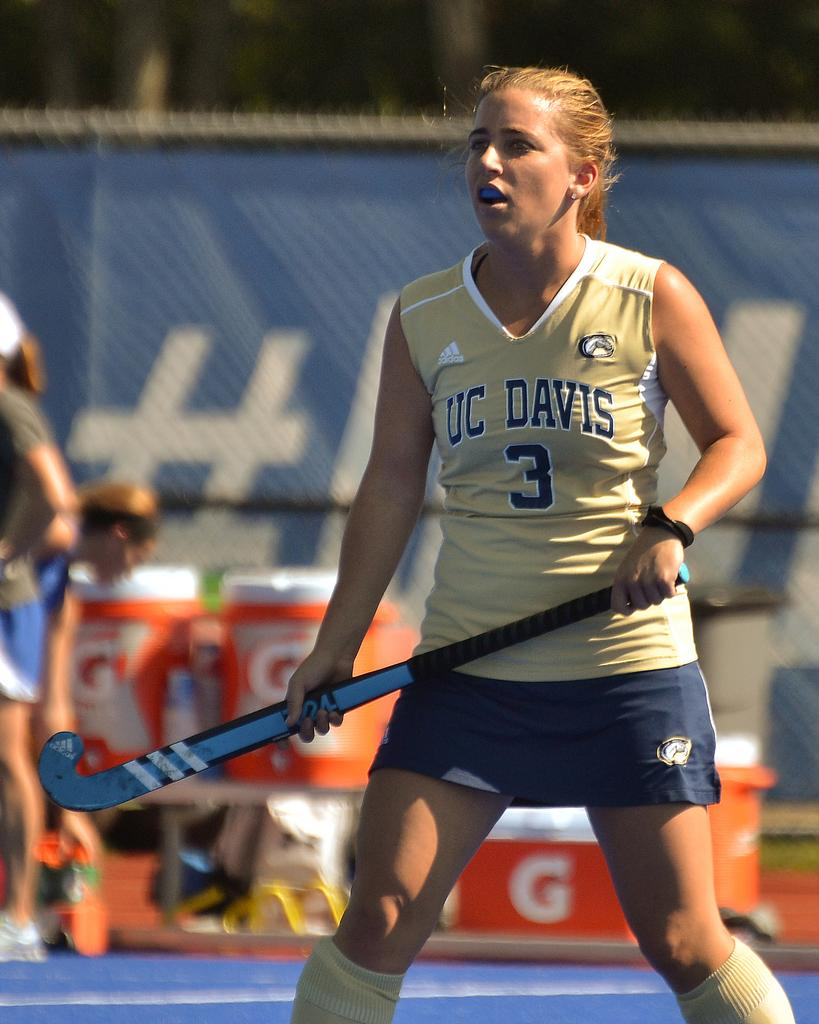<image>
Present a compact description of the photo's key features. a young white teen playing a sport holding a stick 